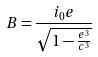Convert formula to latex. <formula><loc_0><loc_0><loc_500><loc_500>B = \frac { i _ { 0 } e } { \sqrt { 1 - \frac { e ^ { 3 } } { c ^ { 3 } } } }</formula> 